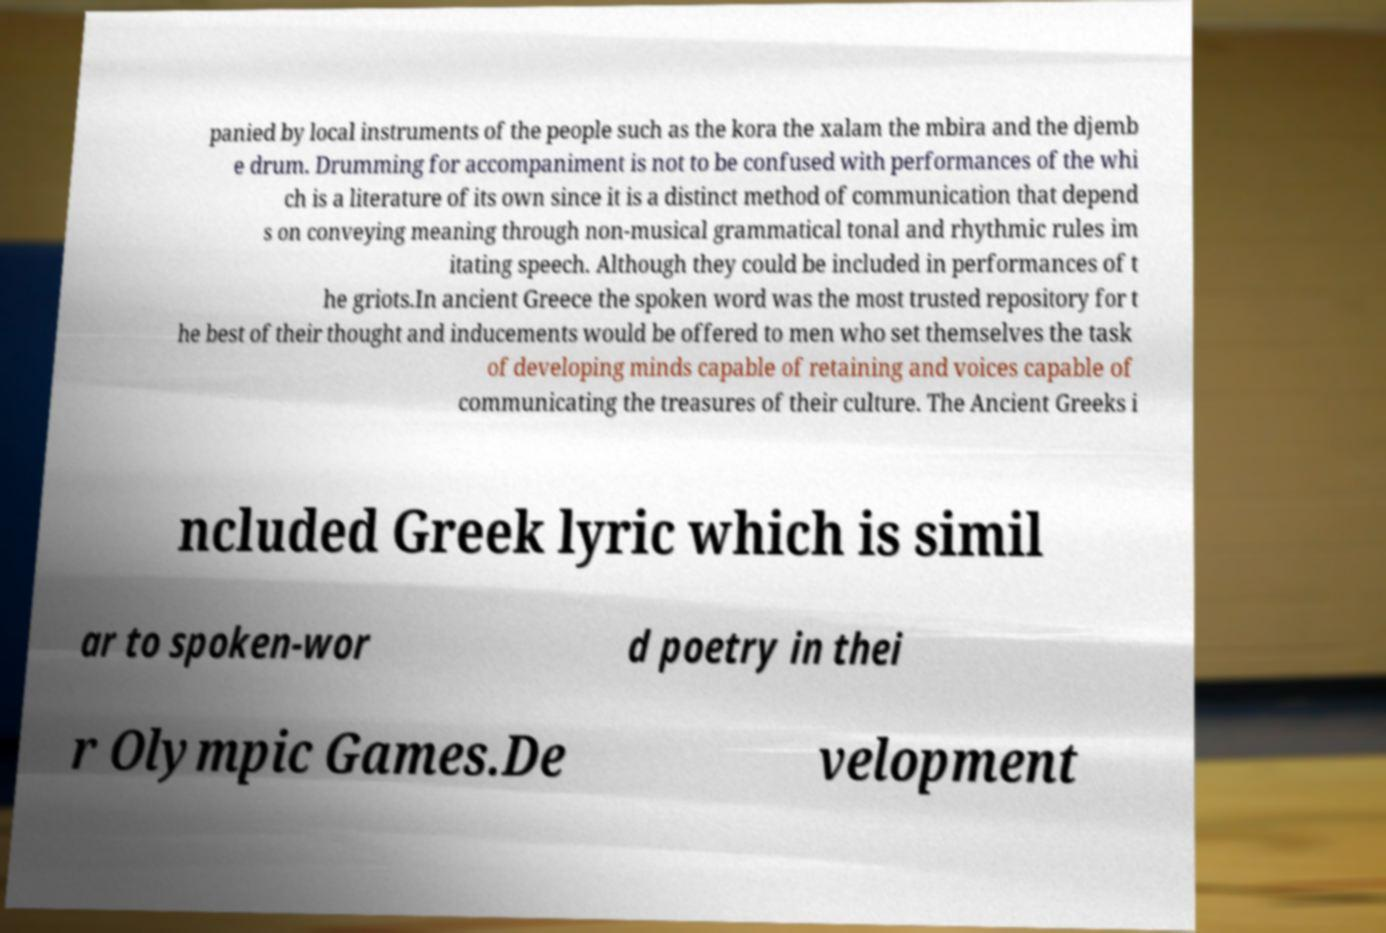There's text embedded in this image that I need extracted. Can you transcribe it verbatim? panied by local instruments of the people such as the kora the xalam the mbira and the djemb e drum. Drumming for accompaniment is not to be confused with performances of the whi ch is a literature of its own since it is a distinct method of communication that depend s on conveying meaning through non-musical grammatical tonal and rhythmic rules im itating speech. Although they could be included in performances of t he griots.In ancient Greece the spoken word was the most trusted repository for t he best of their thought and inducements would be offered to men who set themselves the task of developing minds capable of retaining and voices capable of communicating the treasures of their culture. The Ancient Greeks i ncluded Greek lyric which is simil ar to spoken-wor d poetry in thei r Olympic Games.De velopment 